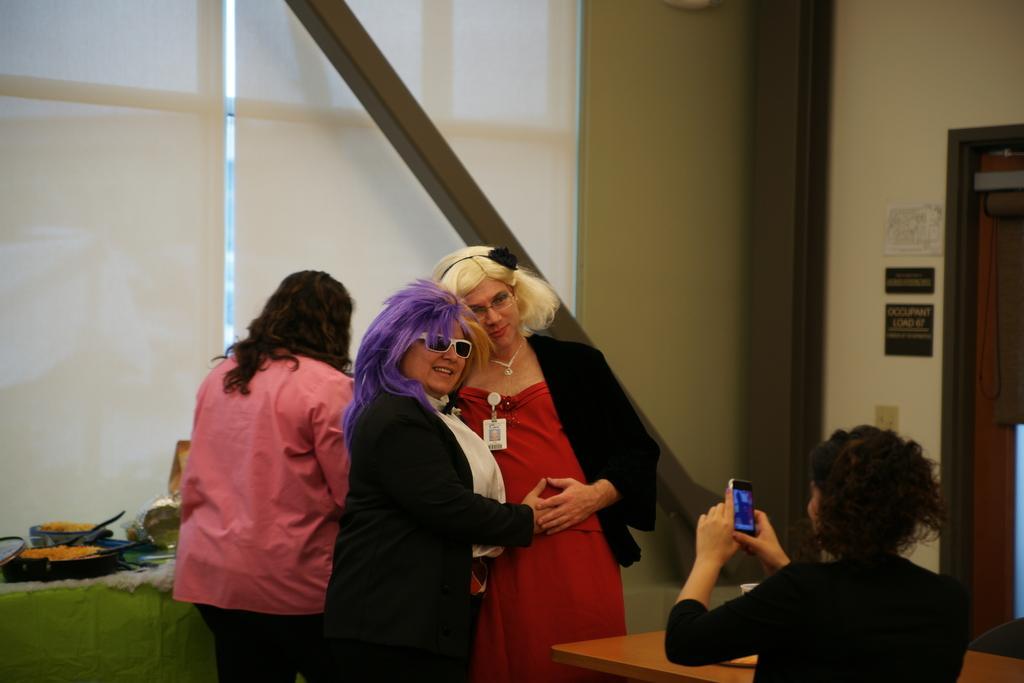How would you summarize this image in a sentence or two? In this image we can see women standing on the floor. In the background we can see cooking pans, doors, name plates, switch board, walls and an iron bar. 